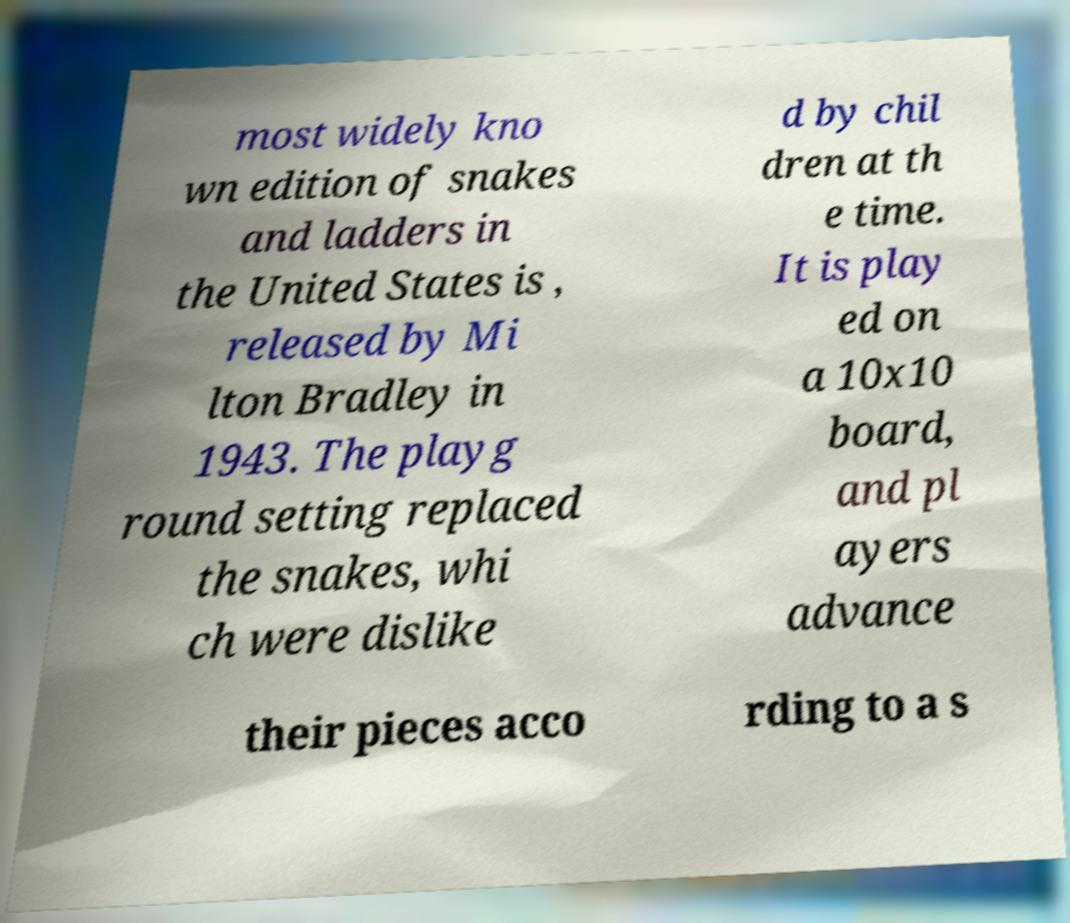Could you extract and type out the text from this image? most widely kno wn edition of snakes and ladders in the United States is , released by Mi lton Bradley in 1943. The playg round setting replaced the snakes, whi ch were dislike d by chil dren at th e time. It is play ed on a 10x10 board, and pl ayers advance their pieces acco rding to a s 